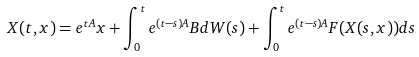<formula> <loc_0><loc_0><loc_500><loc_500>X ( t , x ) = e ^ { t A } x + \int _ { 0 } ^ { t } e ^ { ( t - s ) A } B d W ( s ) + \int _ { 0 } ^ { t } e ^ { ( t - s ) A } F ( X ( s , x ) ) d s</formula> 